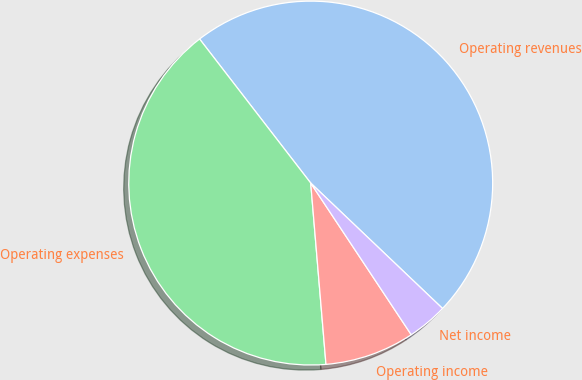Convert chart. <chart><loc_0><loc_0><loc_500><loc_500><pie_chart><fcel>Operating revenues<fcel>Operating expenses<fcel>Operating income<fcel>Net income<nl><fcel>47.56%<fcel>40.88%<fcel>7.98%<fcel>3.58%<nl></chart> 